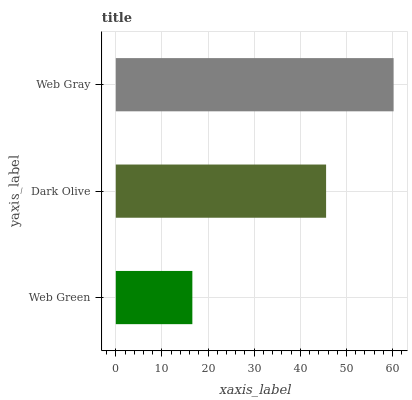Is Web Green the minimum?
Answer yes or no. Yes. Is Web Gray the maximum?
Answer yes or no. Yes. Is Dark Olive the minimum?
Answer yes or no. No. Is Dark Olive the maximum?
Answer yes or no. No. Is Dark Olive greater than Web Green?
Answer yes or no. Yes. Is Web Green less than Dark Olive?
Answer yes or no. Yes. Is Web Green greater than Dark Olive?
Answer yes or no. No. Is Dark Olive less than Web Green?
Answer yes or no. No. Is Dark Olive the high median?
Answer yes or no. Yes. Is Dark Olive the low median?
Answer yes or no. Yes. Is Web Green the high median?
Answer yes or no. No. Is Web Green the low median?
Answer yes or no. No. 